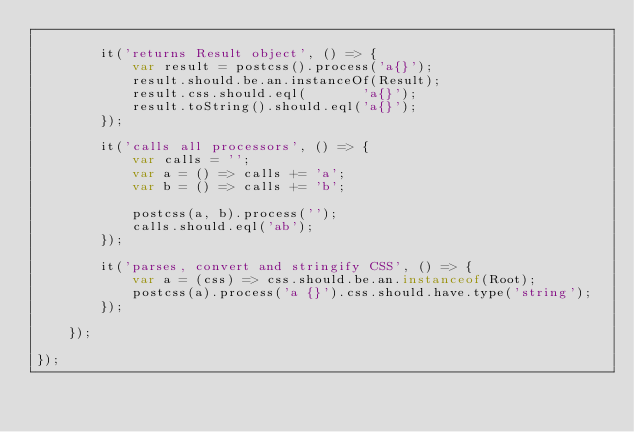Convert code to text. <code><loc_0><loc_0><loc_500><loc_500><_JavaScript_>
        it('returns Result object', () => {
            var result = postcss().process('a{}');
            result.should.be.an.instanceOf(Result);
            result.css.should.eql(       'a{}');
            result.toString().should.eql('a{}');
        });

        it('calls all processors', () => {
            var calls = '';
            var a = () => calls += 'a';
            var b = () => calls += 'b';

            postcss(a, b).process('');
            calls.should.eql('ab');
        });

        it('parses, convert and stringify CSS', () => {
            var a = (css) => css.should.be.an.instanceof(Root);
            postcss(a).process('a {}').css.should.have.type('string');
        });

    });

});
</code> 